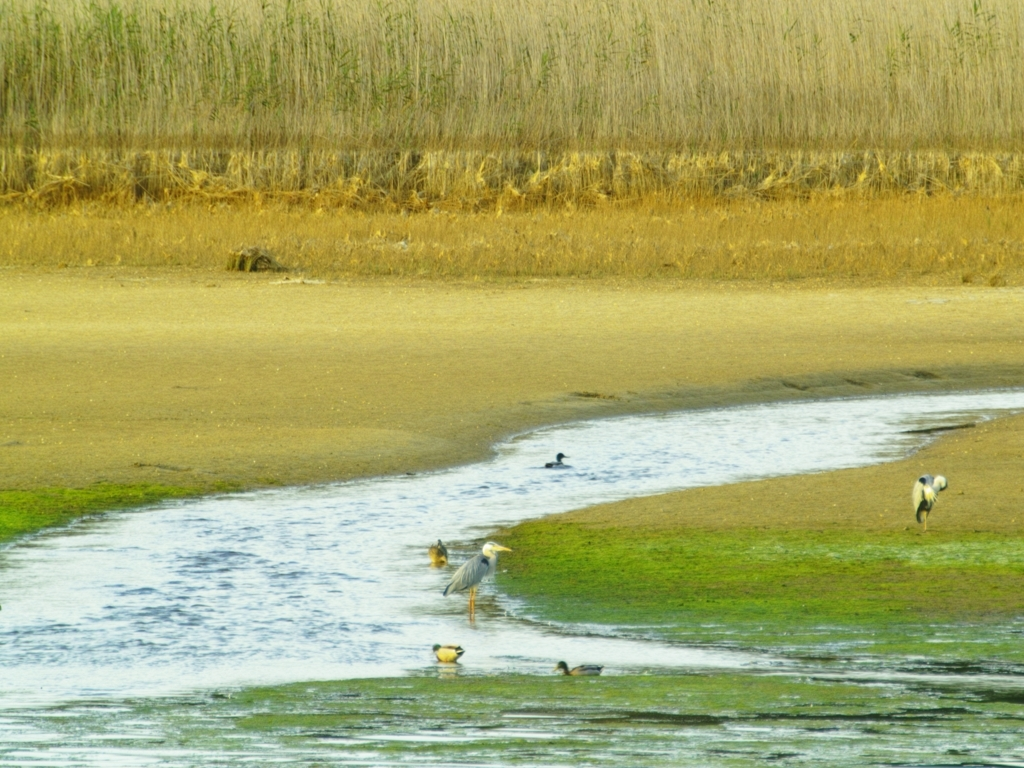Is there anything in this image that indicates human impact on this habitat? There are no immediate signs of human impact visible in this particular frame, such as litter or structures. However, the water's edge and the condition of the vegetation could indirectly suggest water level management or nearby agricultural practices affecting the habitat. 